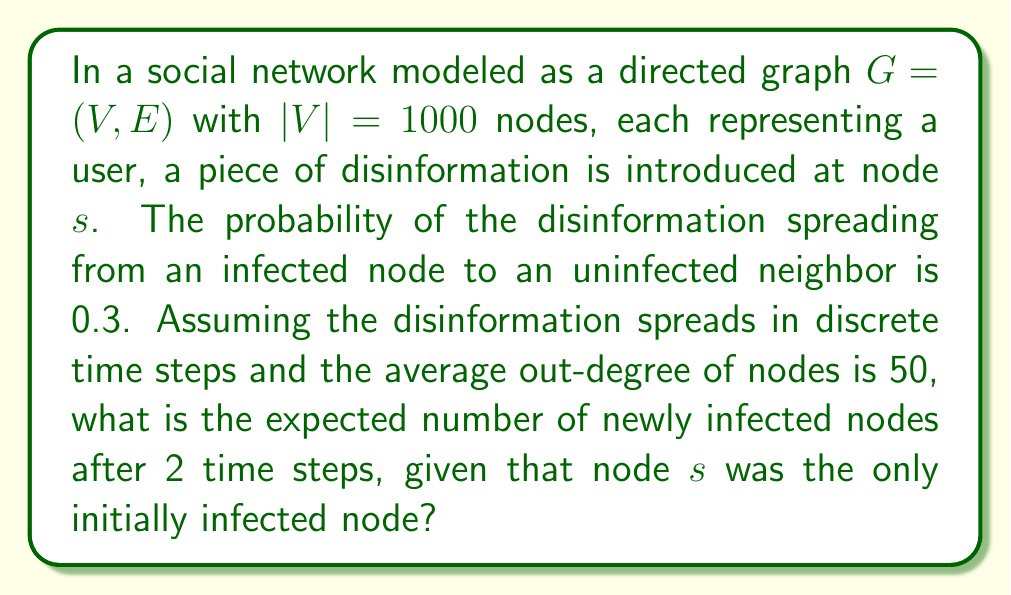Can you answer this question? Let's approach this step-by-step:

1) In the first time step, node $s$ can potentially infect its neighbors.
   - Average out-degree is 50, so $s$ has approximately 50 neighbors.
   - Probability of infection for each neighbor is 0.3.
   - Expected number of newly infected nodes in step 1: $E_1 = 50 * 0.3 = 15$

2) In the second time step, both $s$ and the newly infected nodes from step 1 can spread the disinformation.
   - Total number of potentially infecting nodes: $1 + 15 = 16$
   - Each of these 16 nodes has approximately 50 neighbors.
   - However, some of these neighbors are already infected or overlapping.

3) To account for overlap, we can use the approximation that the number of uninfected neighbors for each node in step 2 is proportional to the fraction of uninfected nodes in the network.
   - Fraction of uninfected nodes after step 1: $(1000 - 16) / 1000 = 0.984$

4) Expected number of newly infected nodes in step 2:
   $$E_2 = 16 * 50 * 0.984 * 0.3 = 235.2$$

Therefore, the expected number of newly infected nodes after 2 time steps is approximately 235.
Answer: 235 